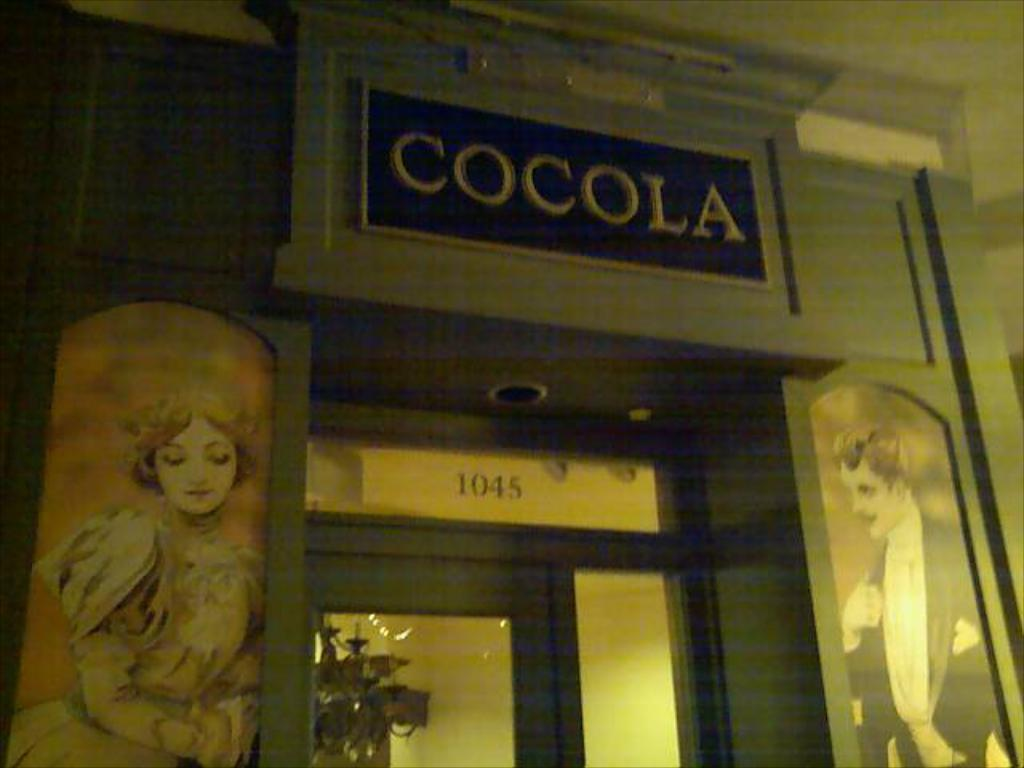What type of structure is present in the image? There is a building in the image. What can be seen on the building? The building has images and text on it. Is there a way to enter the building? Yes, there is a door in the building. What can be seen through the door? The door provides a view of a wall. What type of plant is visible through the door? There is a houseplant visible through the door. How many bananas are hanging from the ceiling in the image? There are no bananas present in the image. Can you tell me how much salt is on the floor in the image? There is no salt visible on the floor in the image. 